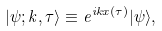<formula> <loc_0><loc_0><loc_500><loc_500>| \psi ; k , \tau \rangle \equiv e ^ { i k x ( \tau ) } | \psi \rangle ,</formula> 